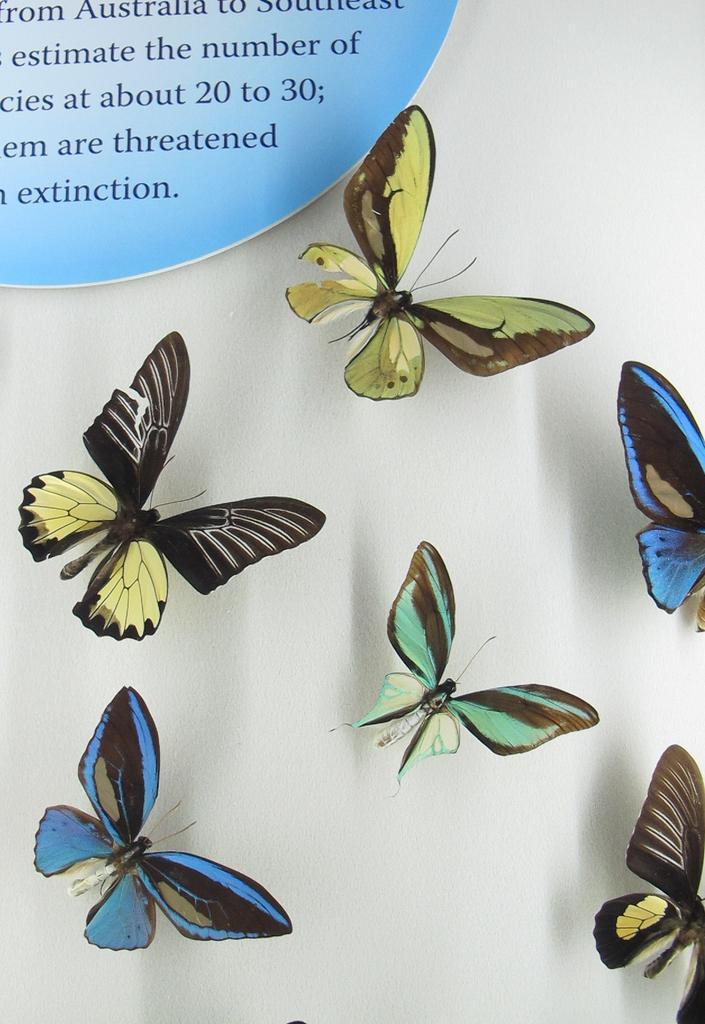Please provide a concise description of this image. In this image I can see few butterflies. In the top left there is some edited text. The background is in white color. 